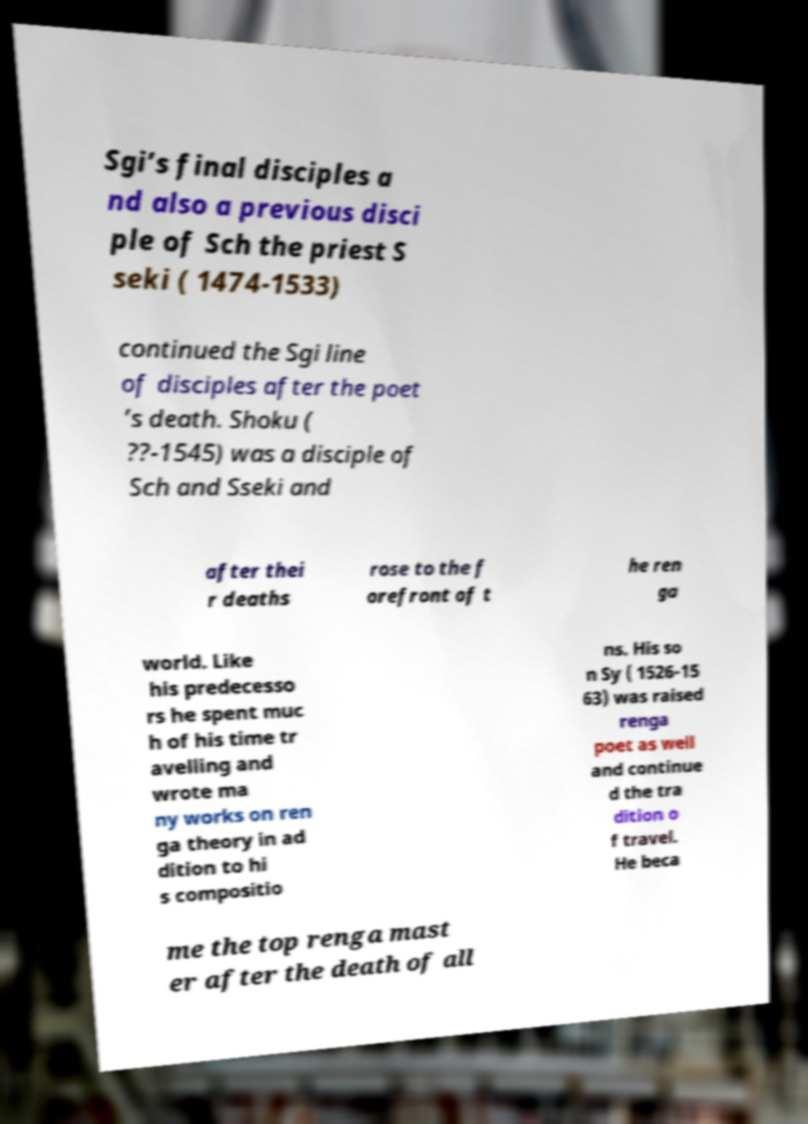Could you assist in decoding the text presented in this image and type it out clearly? Sgi’s final disciples a nd also a previous disci ple of Sch the priest S seki ( 1474-1533) continued the Sgi line of disciples after the poet ’s death. Shoku ( ??-1545) was a disciple of Sch and Sseki and after thei r deaths rose to the f orefront of t he ren ga world. Like his predecesso rs he spent muc h of his time tr avelling and wrote ma ny works on ren ga theory in ad dition to hi s compositio ns. His so n Sy ( 1526-15 63) was raised renga poet as well and continue d the tra dition o f travel. He beca me the top renga mast er after the death of all 